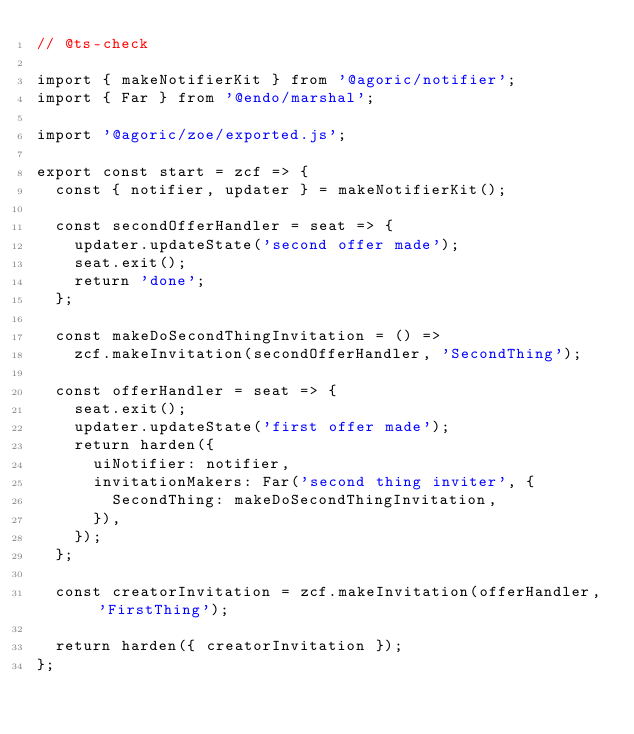Convert code to text. <code><loc_0><loc_0><loc_500><loc_500><_JavaScript_>// @ts-check

import { makeNotifierKit } from '@agoric/notifier';
import { Far } from '@endo/marshal';

import '@agoric/zoe/exported.js';

export const start = zcf => {
  const { notifier, updater } = makeNotifierKit();

  const secondOfferHandler = seat => {
    updater.updateState('second offer made');
    seat.exit();
    return 'done';
  };

  const makeDoSecondThingInvitation = () =>
    zcf.makeInvitation(secondOfferHandler, 'SecondThing');

  const offerHandler = seat => {
    seat.exit();
    updater.updateState('first offer made');
    return harden({
      uiNotifier: notifier,
      invitationMakers: Far('second thing inviter', {
        SecondThing: makeDoSecondThingInvitation,
      }),
    });
  };

  const creatorInvitation = zcf.makeInvitation(offerHandler, 'FirstThing');

  return harden({ creatorInvitation });
};
</code> 